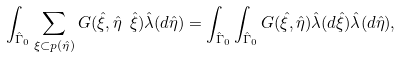<formula> <loc_0><loc_0><loc_500><loc_500>\int _ { \hat { \Gamma } _ { 0 } } \sum _ { \xi \subset p ( \hat { \eta } ) } G ( \hat { \xi } , \hat { \eta } \ \hat { \xi } ) \hat { \lambda } ( d \hat { \eta } ) = \int _ { \hat { \Gamma } _ { 0 } } \int _ { \hat { \Gamma } _ { 0 } } G ( \hat { \xi } , \hat { \eta } ) \hat { \lambda } ( d \hat { \xi } ) \hat { \lambda } ( d \hat { \eta } ) ,</formula> 